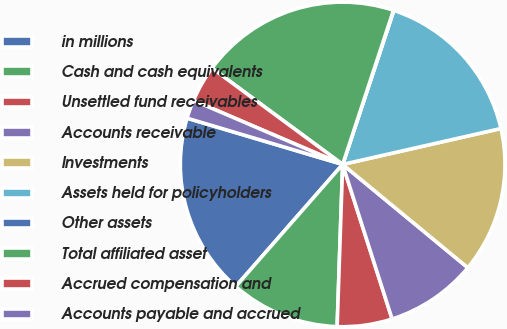<chart> <loc_0><loc_0><loc_500><loc_500><pie_chart><fcel>in millions<fcel>Cash and cash equivalents<fcel>Unsettled fund receivables<fcel>Accounts receivable<fcel>Investments<fcel>Assets held for policyholders<fcel>Other assets<fcel>Total affiliated asset<fcel>Accrued compensation and<fcel>Accounts payable and accrued<nl><fcel>18.15%<fcel>10.91%<fcel>5.47%<fcel>9.09%<fcel>14.53%<fcel>16.34%<fcel>0.04%<fcel>19.96%<fcel>3.66%<fcel>1.85%<nl></chart> 